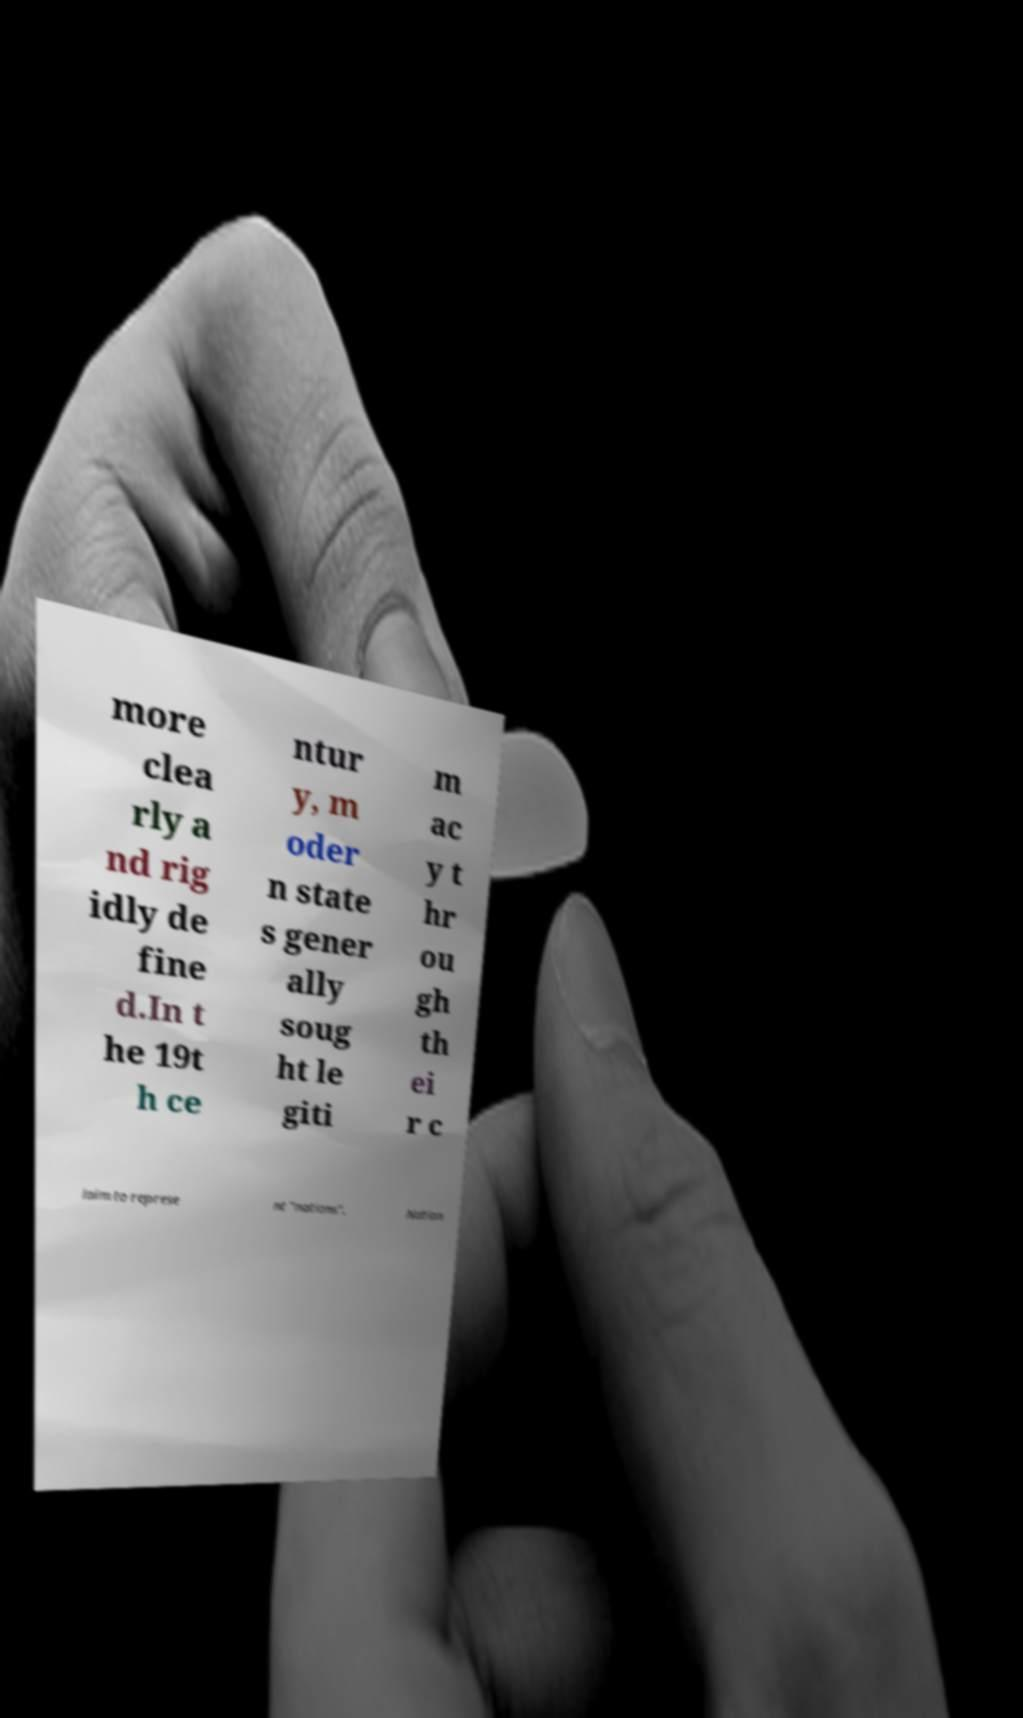There's text embedded in this image that I need extracted. Can you transcribe it verbatim? more clea rly a nd rig idly de fine d.In t he 19t h ce ntur y, m oder n state s gener ally soug ht le giti m ac y t hr ou gh th ei r c laim to represe nt "nations". Nation 